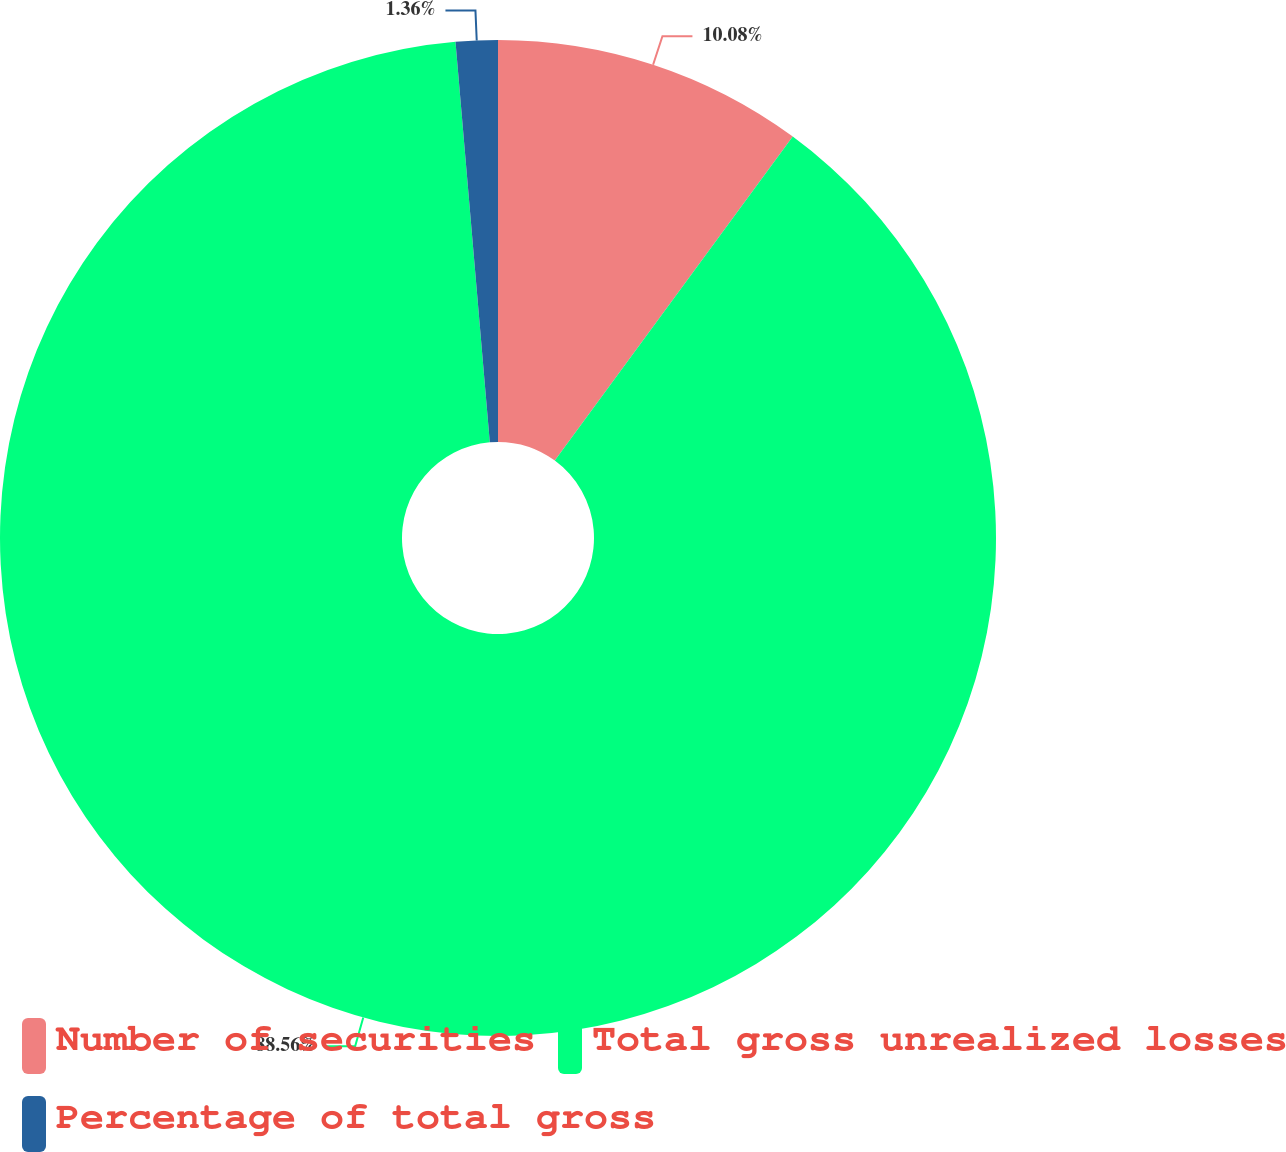Convert chart. <chart><loc_0><loc_0><loc_500><loc_500><pie_chart><fcel>Number of securities<fcel>Total gross unrealized losses<fcel>Percentage of total gross<nl><fcel>10.08%<fcel>88.55%<fcel>1.36%<nl></chart> 